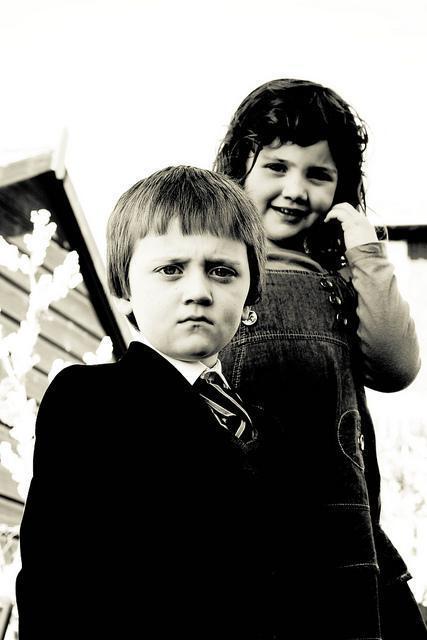How many people can be seen?
Give a very brief answer. 2. 